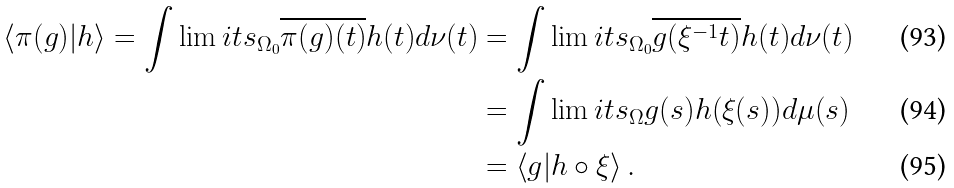Convert formula to latex. <formula><loc_0><loc_0><loc_500><loc_500>\left \langle \pi ( g ) | h \right \rangle = \int \lim i t s _ { \Omega _ { 0 } } \overline { \pi ( g ) ( t ) } h ( t ) d \nu ( t ) & = \int \lim i t s _ { \Omega _ { 0 } } \overline { g ( \xi ^ { - 1 } t ) } h ( t ) d \nu ( t ) \\ & = \int \lim i t s _ { \Omega } g ( s ) h ( \xi ( s ) ) d \mu ( s ) \\ & = \left \langle g | h \circ \xi \right \rangle .</formula> 